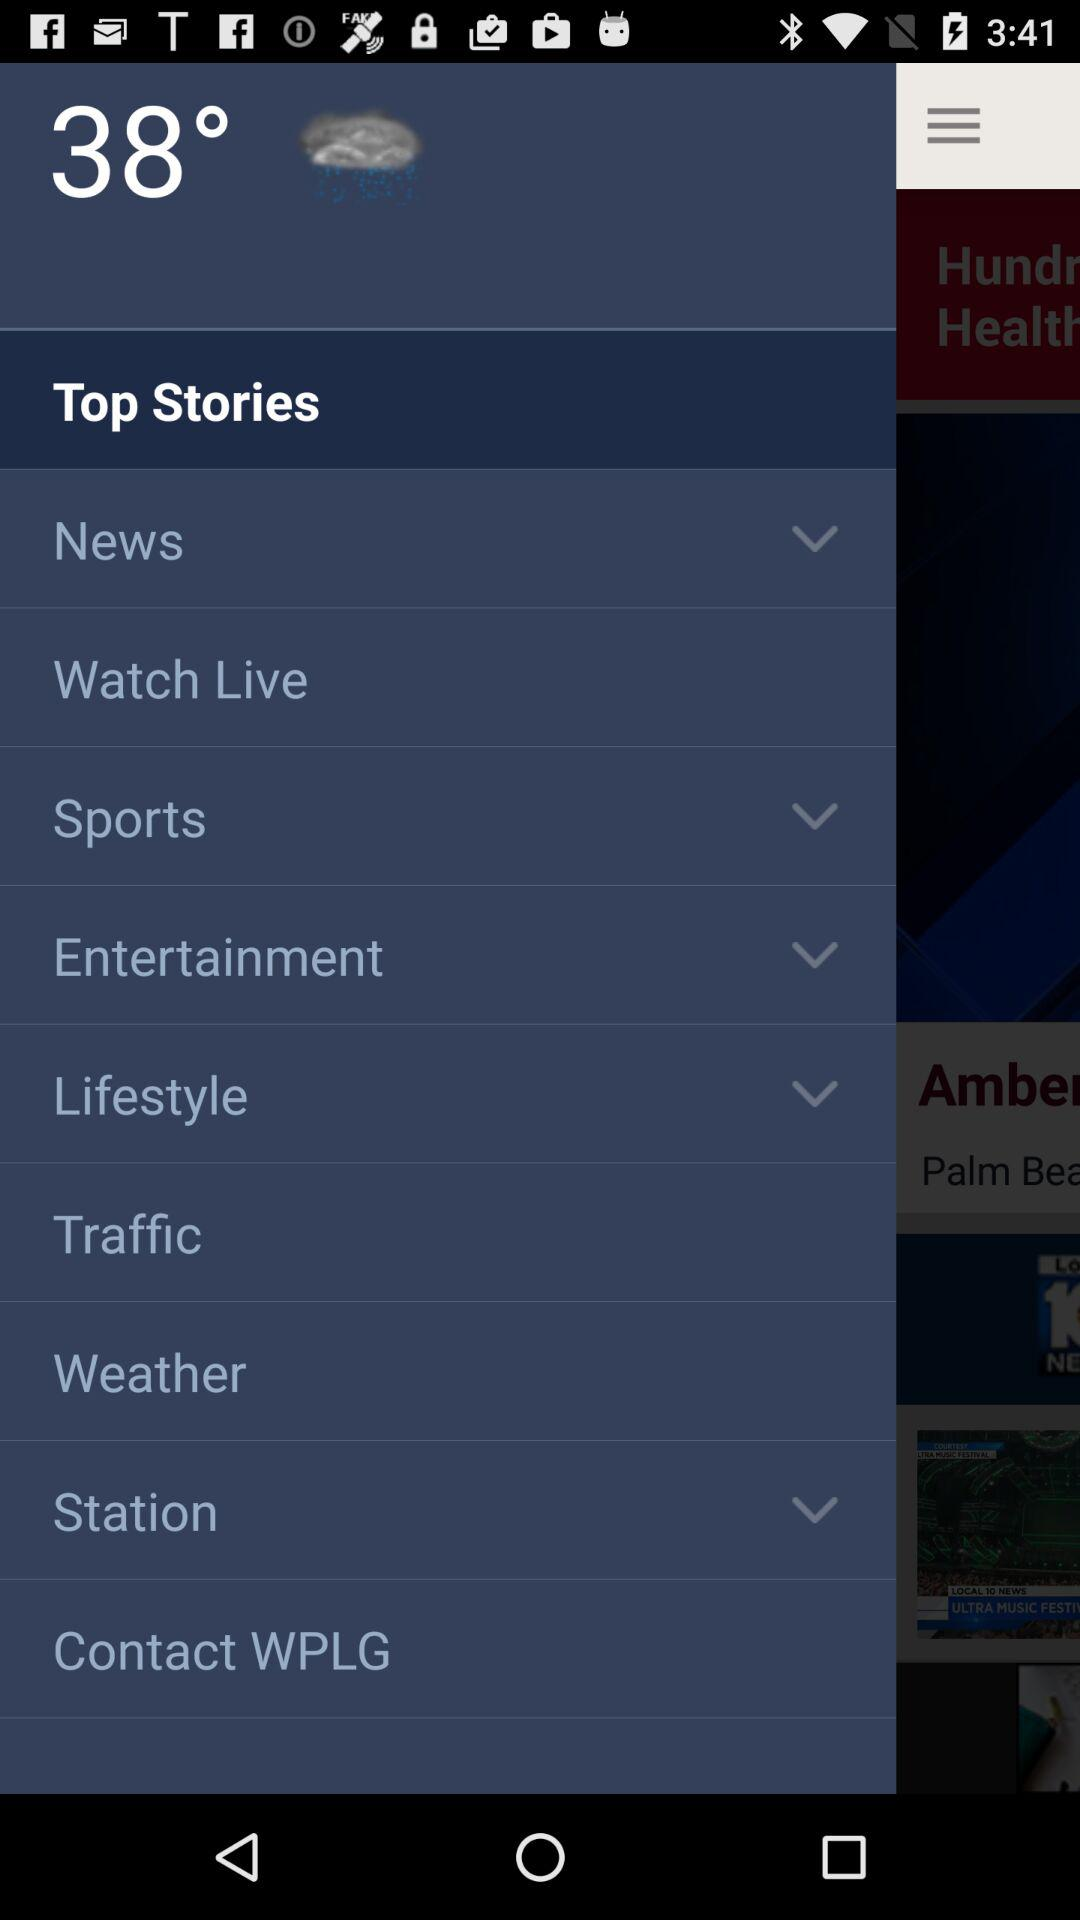Is the temperature measured in Celsius or Fahrenheit?
When the provided information is insufficient, respond with <no answer>. <no answer> 